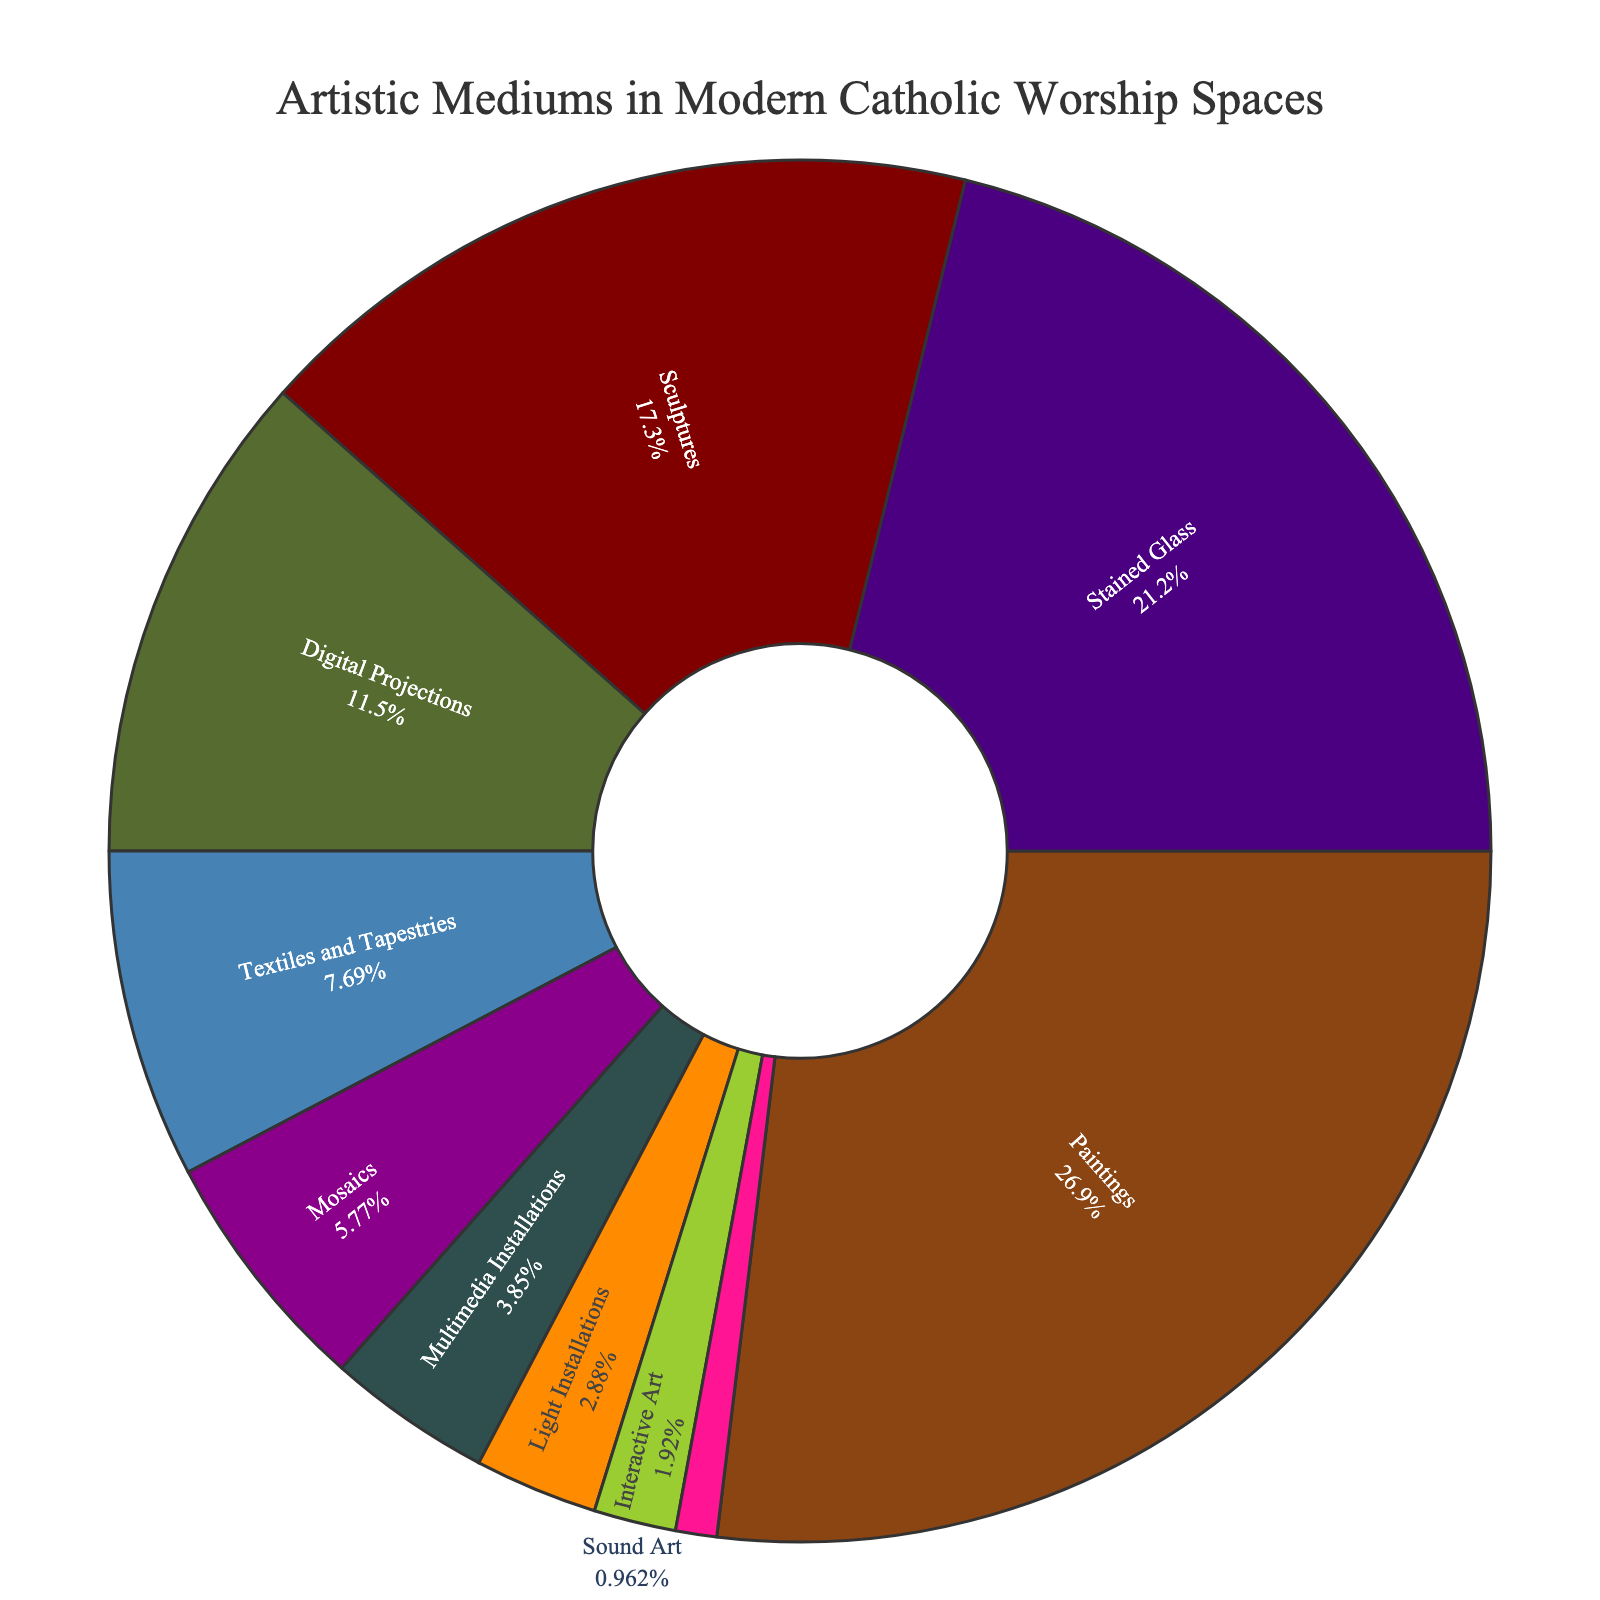What medium has the largest percentage in modern Catholic worship spaces? The chart shows various artistic mediums along with their percentages. By visual inspection, "Paintings" occupies the largest section of the pie chart.
Answer: Paintings What is the combined percentage of Sculptures and Digital Projections? To find the combined percentage, add the individual percentages of Sculptures (18%) and Digital Projections (12%).
Answer: 30% Which medium has a smaller percentage: Light Installations or Mosaics? By comparing the sizes of their pie sections, Light Installations has a smaller portion. Light Installations is 3%, and Mosaics is 6%.
Answer: Light Installations How much greater is the percentage of Paintings compared to Sound Art? Subtract the percentage of Sound Art (1%) from the percentage of Paintings (28%).
Answer: 27% Rank the top three artistic mediums used in modern Catholic worship spaces. By examining the sections of the pie chart, the top three mediums in descending order are Paintings (28%), Stained Glass (22%), and Sculptures (18%).
Answer: Paintings, Stained Glass, Sculptures Which medium occupies exactly one-tenth of the pie chart? Textiles and Tapestries occupy 8%, which is close to one-tenth, but considering only exact values, there is none with exactly 10%. Therefore, no medium occupies exactly 10% of the pie chart.
Answer: None Compare the segments: which has a larger percentage, Interactive Art or Sound Art? Interactive Art has a percentage of 2% while Sound Art has 1%. Therefore, Interactive Art has a larger percentage.
Answer: Interactive Art What percentage of artistic mediums other than Paintings, Sculptures, and Stained Glass is used? Add percentages of all mediums except Paintings (28%), Sculptures (18%), and Stained Glass (22%). The sum of the rest is 32%.
Answer: 32% What is the color associated with Sculptures on the pie chart? The section labeled Sculptures is in a color, which we can describe visually as a specific shade (likely one among browns, reds, greens, etc.). By looking at the legend, Sculptures are assigned a particular color (e.g., a shade of red).
Answer: (Corresponding color) Is the percentage of Mosaics greater than the sum of Sound Art and Interactive Art? The percentage of Mosaics is 6%, and the sum of Sound Art (1%) and Interactive Art (2%) is 3%. Therefore, 6% is greater than 3%.
Answer: Yes 